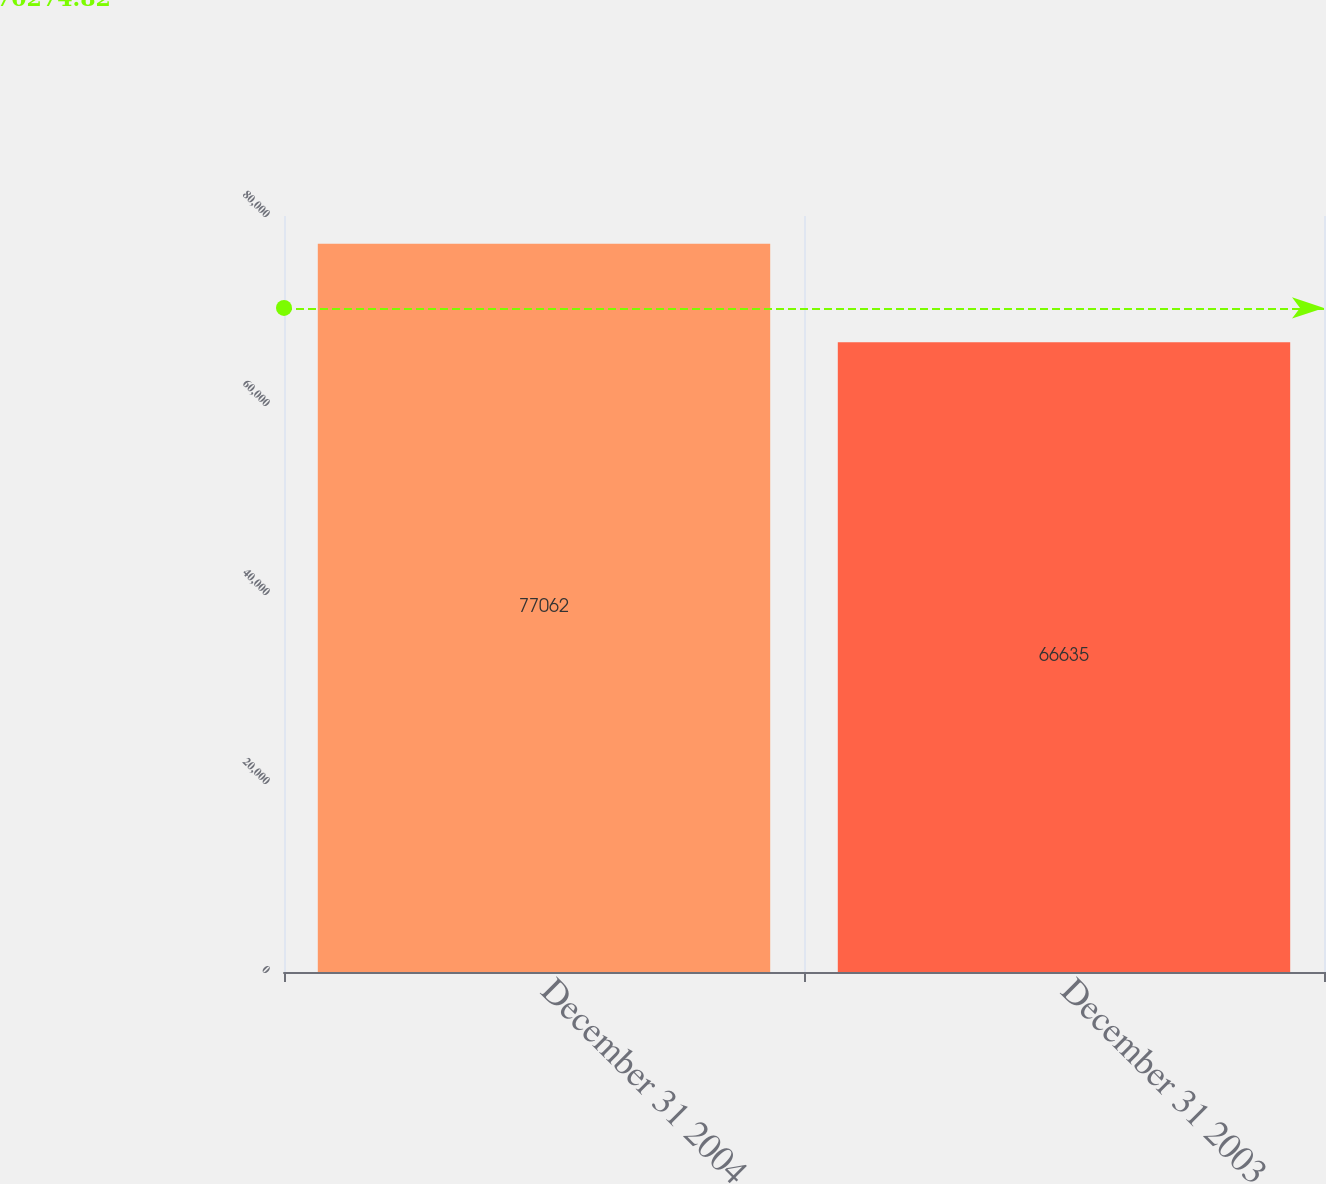<chart> <loc_0><loc_0><loc_500><loc_500><bar_chart><fcel>December 31 2004<fcel>December 31 2003<nl><fcel>77062<fcel>66635<nl></chart> 